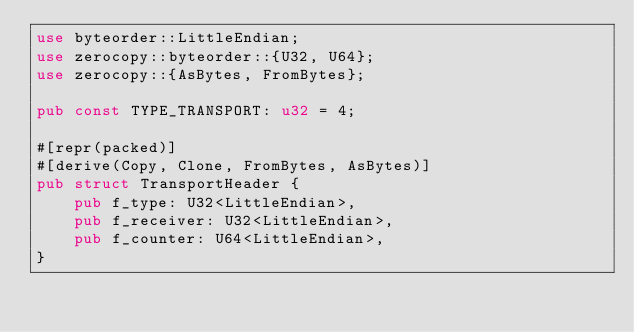Convert code to text. <code><loc_0><loc_0><loc_500><loc_500><_Rust_>use byteorder::LittleEndian;
use zerocopy::byteorder::{U32, U64};
use zerocopy::{AsBytes, FromBytes};

pub const TYPE_TRANSPORT: u32 = 4;

#[repr(packed)]
#[derive(Copy, Clone, FromBytes, AsBytes)]
pub struct TransportHeader {
    pub f_type: U32<LittleEndian>,
    pub f_receiver: U32<LittleEndian>,
    pub f_counter: U64<LittleEndian>,
}
</code> 